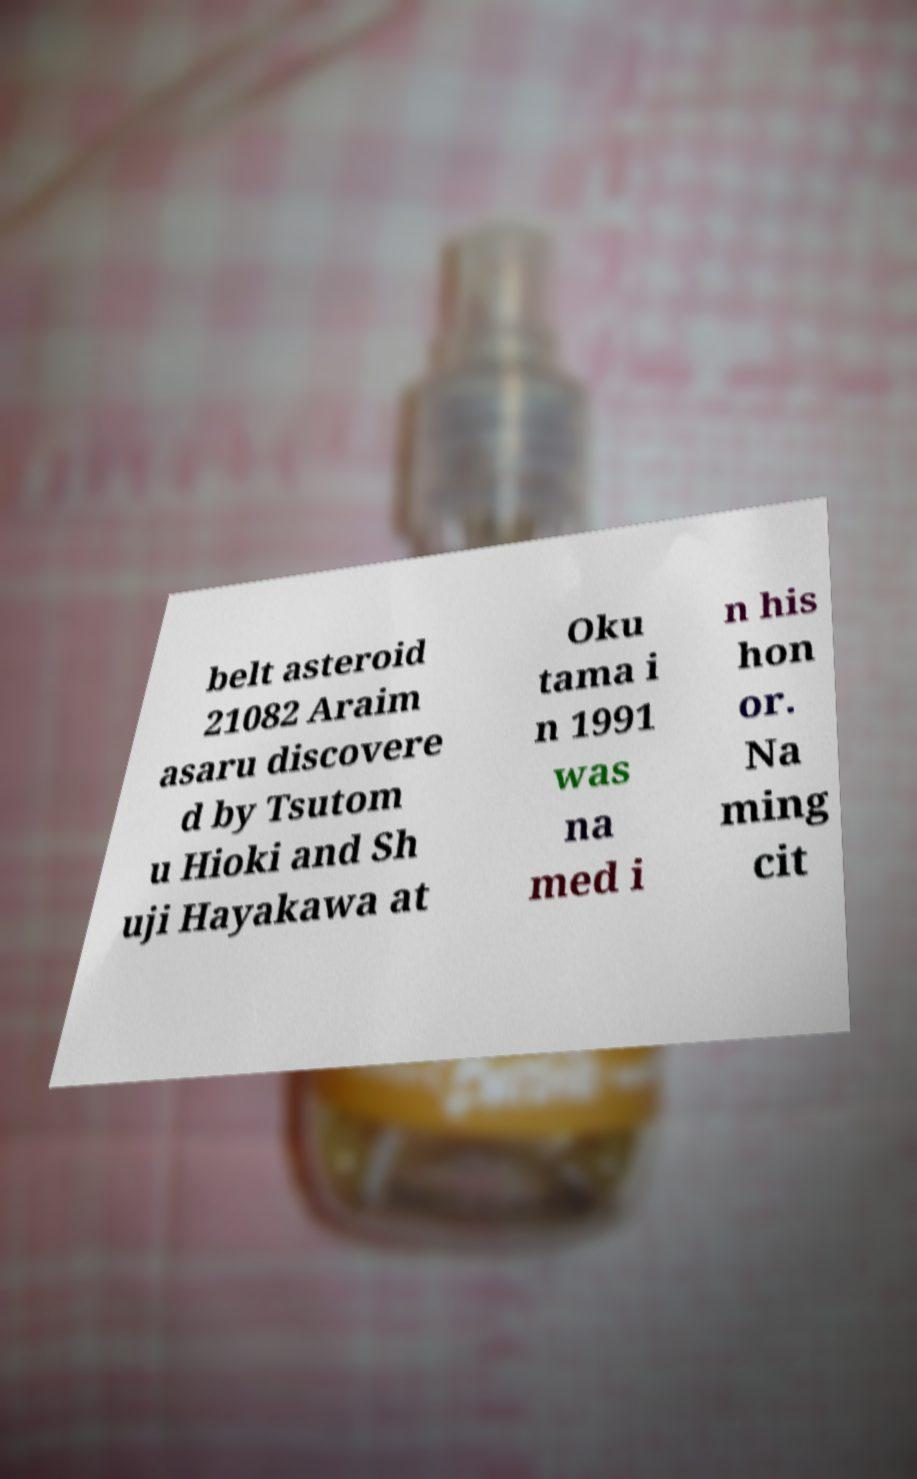There's text embedded in this image that I need extracted. Can you transcribe it verbatim? belt asteroid 21082 Araim asaru discovere d by Tsutom u Hioki and Sh uji Hayakawa at Oku tama i n 1991 was na med i n his hon or. Na ming cit 